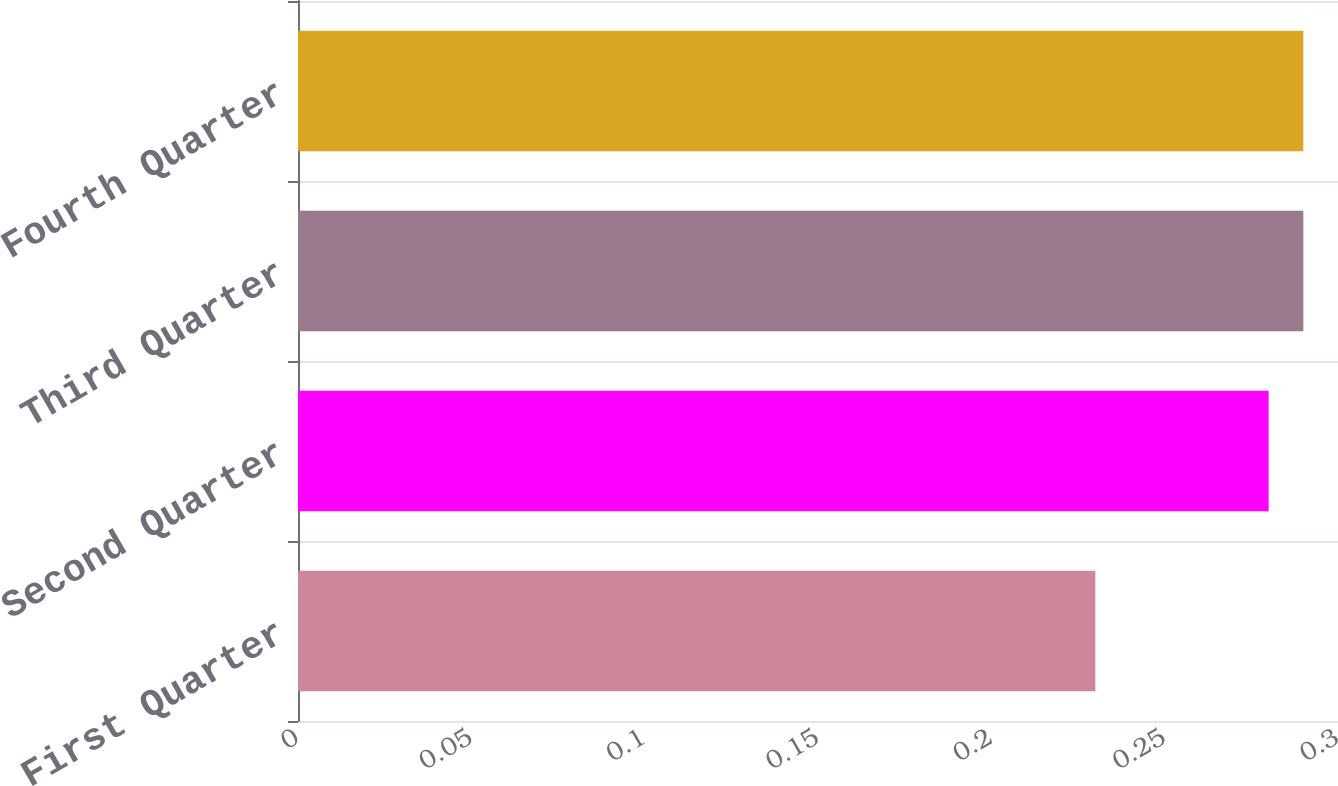<chart> <loc_0><loc_0><loc_500><loc_500><bar_chart><fcel>First Quarter<fcel>Second Quarter<fcel>Third Quarter<fcel>Fourth Quarter<nl><fcel>0.23<fcel>0.28<fcel>0.29<fcel>0.29<nl></chart> 